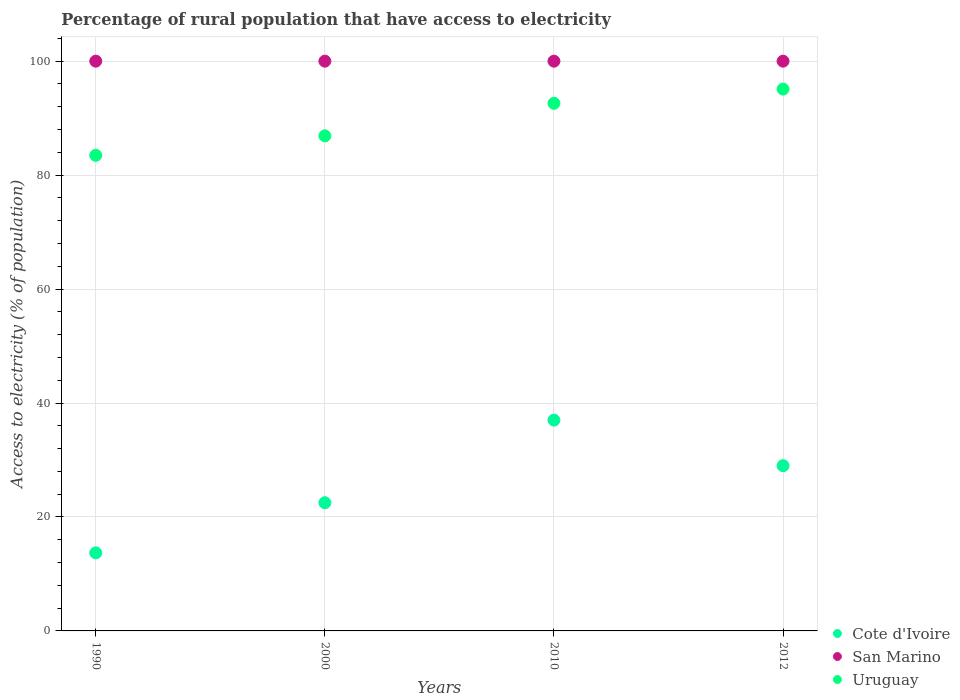How many different coloured dotlines are there?
Offer a very short reply. 3. What is the percentage of rural population that have access to electricity in Cote d'Ivoire in 1990?
Provide a succinct answer. 13.7. Across all years, what is the maximum percentage of rural population that have access to electricity in Uruguay?
Keep it short and to the point. 95.1. In which year was the percentage of rural population that have access to electricity in Uruguay maximum?
Your answer should be very brief. 2012. What is the total percentage of rural population that have access to electricity in Cote d'Ivoire in the graph?
Your answer should be compact. 102.2. What is the difference between the percentage of rural population that have access to electricity in Uruguay in 1990 and that in 2010?
Ensure brevity in your answer.  -9.13. What is the difference between the percentage of rural population that have access to electricity in Cote d'Ivoire in 1990 and the percentage of rural population that have access to electricity in San Marino in 2000?
Your answer should be compact. -86.3. In the year 1990, what is the difference between the percentage of rural population that have access to electricity in Cote d'Ivoire and percentage of rural population that have access to electricity in Uruguay?
Your answer should be compact. -69.77. What is the ratio of the percentage of rural population that have access to electricity in Cote d'Ivoire in 1990 to that in 2000?
Your answer should be compact. 0.61. What is the difference between the highest and the second highest percentage of rural population that have access to electricity in San Marino?
Ensure brevity in your answer.  0. Is the percentage of rural population that have access to electricity in Cote d'Ivoire strictly greater than the percentage of rural population that have access to electricity in San Marino over the years?
Keep it short and to the point. No. Is the percentage of rural population that have access to electricity in San Marino strictly less than the percentage of rural population that have access to electricity in Cote d'Ivoire over the years?
Ensure brevity in your answer.  No. How many dotlines are there?
Ensure brevity in your answer.  3. What is the difference between two consecutive major ticks on the Y-axis?
Your answer should be very brief. 20. Are the values on the major ticks of Y-axis written in scientific E-notation?
Offer a terse response. No. Does the graph contain any zero values?
Offer a very short reply. No. How many legend labels are there?
Offer a very short reply. 3. How are the legend labels stacked?
Your answer should be compact. Vertical. What is the title of the graph?
Provide a succinct answer. Percentage of rural population that have access to electricity. What is the label or title of the X-axis?
Keep it short and to the point. Years. What is the label or title of the Y-axis?
Keep it short and to the point. Access to electricity (% of population). What is the Access to electricity (% of population) in San Marino in 1990?
Give a very brief answer. 100. What is the Access to electricity (% of population) in Uruguay in 1990?
Give a very brief answer. 83.47. What is the Access to electricity (% of population) of Uruguay in 2000?
Provide a succinct answer. 86.9. What is the Access to electricity (% of population) of Cote d'Ivoire in 2010?
Provide a succinct answer. 37. What is the Access to electricity (% of population) in Uruguay in 2010?
Make the answer very short. 92.6. What is the Access to electricity (% of population) in Cote d'Ivoire in 2012?
Offer a very short reply. 29. What is the Access to electricity (% of population) of San Marino in 2012?
Your answer should be compact. 100. What is the Access to electricity (% of population) in Uruguay in 2012?
Your response must be concise. 95.1. Across all years, what is the maximum Access to electricity (% of population) of Cote d'Ivoire?
Provide a short and direct response. 37. Across all years, what is the maximum Access to electricity (% of population) of Uruguay?
Your response must be concise. 95.1. Across all years, what is the minimum Access to electricity (% of population) of Cote d'Ivoire?
Make the answer very short. 13.7. Across all years, what is the minimum Access to electricity (% of population) of San Marino?
Your answer should be compact. 100. Across all years, what is the minimum Access to electricity (% of population) in Uruguay?
Provide a succinct answer. 83.47. What is the total Access to electricity (% of population) in Cote d'Ivoire in the graph?
Make the answer very short. 102.2. What is the total Access to electricity (% of population) of San Marino in the graph?
Make the answer very short. 400. What is the total Access to electricity (% of population) of Uruguay in the graph?
Provide a succinct answer. 358.07. What is the difference between the Access to electricity (% of population) in Uruguay in 1990 and that in 2000?
Offer a terse response. -3.43. What is the difference between the Access to electricity (% of population) in Cote d'Ivoire in 1990 and that in 2010?
Give a very brief answer. -23.3. What is the difference between the Access to electricity (% of population) in San Marino in 1990 and that in 2010?
Offer a very short reply. 0. What is the difference between the Access to electricity (% of population) in Uruguay in 1990 and that in 2010?
Your answer should be very brief. -9.13. What is the difference between the Access to electricity (% of population) in Cote d'Ivoire in 1990 and that in 2012?
Your answer should be compact. -15.3. What is the difference between the Access to electricity (% of population) in Uruguay in 1990 and that in 2012?
Provide a succinct answer. -11.63. What is the difference between the Access to electricity (% of population) in Uruguay in 2000 and that in 2010?
Make the answer very short. -5.7. What is the difference between the Access to electricity (% of population) in Cote d'Ivoire in 2000 and that in 2012?
Your answer should be very brief. -6.5. What is the difference between the Access to electricity (% of population) of Uruguay in 2000 and that in 2012?
Your answer should be very brief. -8.2. What is the difference between the Access to electricity (% of population) in Uruguay in 2010 and that in 2012?
Offer a very short reply. -2.5. What is the difference between the Access to electricity (% of population) in Cote d'Ivoire in 1990 and the Access to electricity (% of population) in San Marino in 2000?
Provide a short and direct response. -86.3. What is the difference between the Access to electricity (% of population) in Cote d'Ivoire in 1990 and the Access to electricity (% of population) in Uruguay in 2000?
Offer a very short reply. -73.2. What is the difference between the Access to electricity (% of population) in Cote d'Ivoire in 1990 and the Access to electricity (% of population) in San Marino in 2010?
Offer a very short reply. -86.3. What is the difference between the Access to electricity (% of population) of Cote d'Ivoire in 1990 and the Access to electricity (% of population) of Uruguay in 2010?
Your response must be concise. -78.9. What is the difference between the Access to electricity (% of population) in San Marino in 1990 and the Access to electricity (% of population) in Uruguay in 2010?
Your answer should be very brief. 7.4. What is the difference between the Access to electricity (% of population) of Cote d'Ivoire in 1990 and the Access to electricity (% of population) of San Marino in 2012?
Offer a very short reply. -86.3. What is the difference between the Access to electricity (% of population) of Cote d'Ivoire in 1990 and the Access to electricity (% of population) of Uruguay in 2012?
Your answer should be very brief. -81.4. What is the difference between the Access to electricity (% of population) of Cote d'Ivoire in 2000 and the Access to electricity (% of population) of San Marino in 2010?
Make the answer very short. -77.5. What is the difference between the Access to electricity (% of population) in Cote d'Ivoire in 2000 and the Access to electricity (% of population) in Uruguay in 2010?
Provide a short and direct response. -70.1. What is the difference between the Access to electricity (% of population) in Cote d'Ivoire in 2000 and the Access to electricity (% of population) in San Marino in 2012?
Give a very brief answer. -77.5. What is the difference between the Access to electricity (% of population) of Cote d'Ivoire in 2000 and the Access to electricity (% of population) of Uruguay in 2012?
Make the answer very short. -72.6. What is the difference between the Access to electricity (% of population) in Cote d'Ivoire in 2010 and the Access to electricity (% of population) in San Marino in 2012?
Ensure brevity in your answer.  -63. What is the difference between the Access to electricity (% of population) in Cote d'Ivoire in 2010 and the Access to electricity (% of population) in Uruguay in 2012?
Your answer should be compact. -58.1. What is the average Access to electricity (% of population) of Cote d'Ivoire per year?
Offer a very short reply. 25.55. What is the average Access to electricity (% of population) of San Marino per year?
Give a very brief answer. 100. What is the average Access to electricity (% of population) in Uruguay per year?
Your answer should be very brief. 89.52. In the year 1990, what is the difference between the Access to electricity (% of population) in Cote d'Ivoire and Access to electricity (% of population) in San Marino?
Make the answer very short. -86.3. In the year 1990, what is the difference between the Access to electricity (% of population) of Cote d'Ivoire and Access to electricity (% of population) of Uruguay?
Give a very brief answer. -69.77. In the year 1990, what is the difference between the Access to electricity (% of population) in San Marino and Access to electricity (% of population) in Uruguay?
Ensure brevity in your answer.  16.53. In the year 2000, what is the difference between the Access to electricity (% of population) of Cote d'Ivoire and Access to electricity (% of population) of San Marino?
Offer a very short reply. -77.5. In the year 2000, what is the difference between the Access to electricity (% of population) in Cote d'Ivoire and Access to electricity (% of population) in Uruguay?
Your answer should be compact. -64.4. In the year 2000, what is the difference between the Access to electricity (% of population) in San Marino and Access to electricity (% of population) in Uruguay?
Provide a succinct answer. 13.1. In the year 2010, what is the difference between the Access to electricity (% of population) in Cote d'Ivoire and Access to electricity (% of population) in San Marino?
Provide a succinct answer. -63. In the year 2010, what is the difference between the Access to electricity (% of population) of Cote d'Ivoire and Access to electricity (% of population) of Uruguay?
Provide a short and direct response. -55.6. In the year 2010, what is the difference between the Access to electricity (% of population) of San Marino and Access to electricity (% of population) of Uruguay?
Ensure brevity in your answer.  7.4. In the year 2012, what is the difference between the Access to electricity (% of population) of Cote d'Ivoire and Access to electricity (% of population) of San Marino?
Your answer should be compact. -71. In the year 2012, what is the difference between the Access to electricity (% of population) of Cote d'Ivoire and Access to electricity (% of population) of Uruguay?
Your answer should be very brief. -66.1. In the year 2012, what is the difference between the Access to electricity (% of population) in San Marino and Access to electricity (% of population) in Uruguay?
Provide a succinct answer. 4.9. What is the ratio of the Access to electricity (% of population) of Cote d'Ivoire in 1990 to that in 2000?
Make the answer very short. 0.61. What is the ratio of the Access to electricity (% of population) in San Marino in 1990 to that in 2000?
Offer a terse response. 1. What is the ratio of the Access to electricity (% of population) of Uruguay in 1990 to that in 2000?
Keep it short and to the point. 0.96. What is the ratio of the Access to electricity (% of population) in Cote d'Ivoire in 1990 to that in 2010?
Give a very brief answer. 0.37. What is the ratio of the Access to electricity (% of population) in Uruguay in 1990 to that in 2010?
Provide a short and direct response. 0.9. What is the ratio of the Access to electricity (% of population) in Cote d'Ivoire in 1990 to that in 2012?
Keep it short and to the point. 0.47. What is the ratio of the Access to electricity (% of population) of San Marino in 1990 to that in 2012?
Your answer should be compact. 1. What is the ratio of the Access to electricity (% of population) of Uruguay in 1990 to that in 2012?
Offer a terse response. 0.88. What is the ratio of the Access to electricity (% of population) of Cote d'Ivoire in 2000 to that in 2010?
Provide a succinct answer. 0.61. What is the ratio of the Access to electricity (% of population) in Uruguay in 2000 to that in 2010?
Your answer should be compact. 0.94. What is the ratio of the Access to electricity (% of population) in Cote d'Ivoire in 2000 to that in 2012?
Offer a terse response. 0.78. What is the ratio of the Access to electricity (% of population) in Uruguay in 2000 to that in 2012?
Ensure brevity in your answer.  0.91. What is the ratio of the Access to electricity (% of population) of Cote d'Ivoire in 2010 to that in 2012?
Offer a very short reply. 1.28. What is the ratio of the Access to electricity (% of population) of Uruguay in 2010 to that in 2012?
Provide a succinct answer. 0.97. What is the difference between the highest and the second highest Access to electricity (% of population) in San Marino?
Keep it short and to the point. 0. What is the difference between the highest and the lowest Access to electricity (% of population) in Cote d'Ivoire?
Provide a short and direct response. 23.3. What is the difference between the highest and the lowest Access to electricity (% of population) in Uruguay?
Provide a short and direct response. 11.63. 